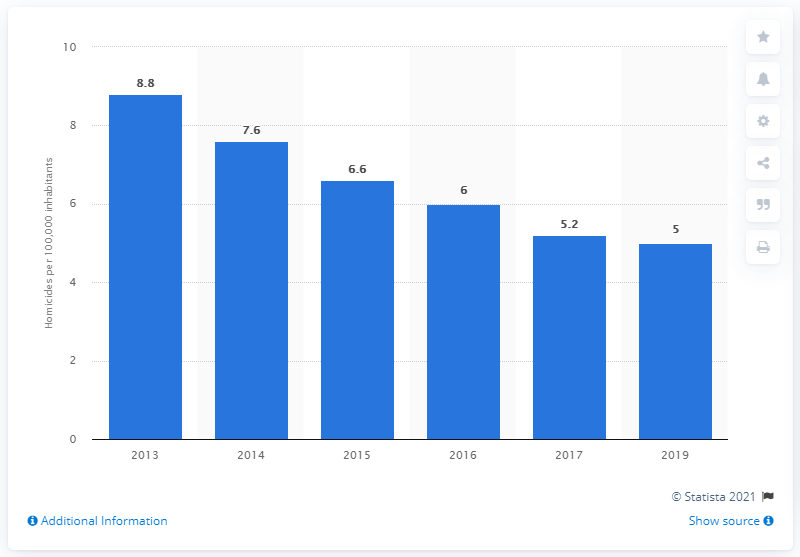List a handful of essential elements in this visual. In 2013, the homicide rate was 8.8 per 100,000 people. In 2019, Argentina experienced the lowest homicide rate in its history. 